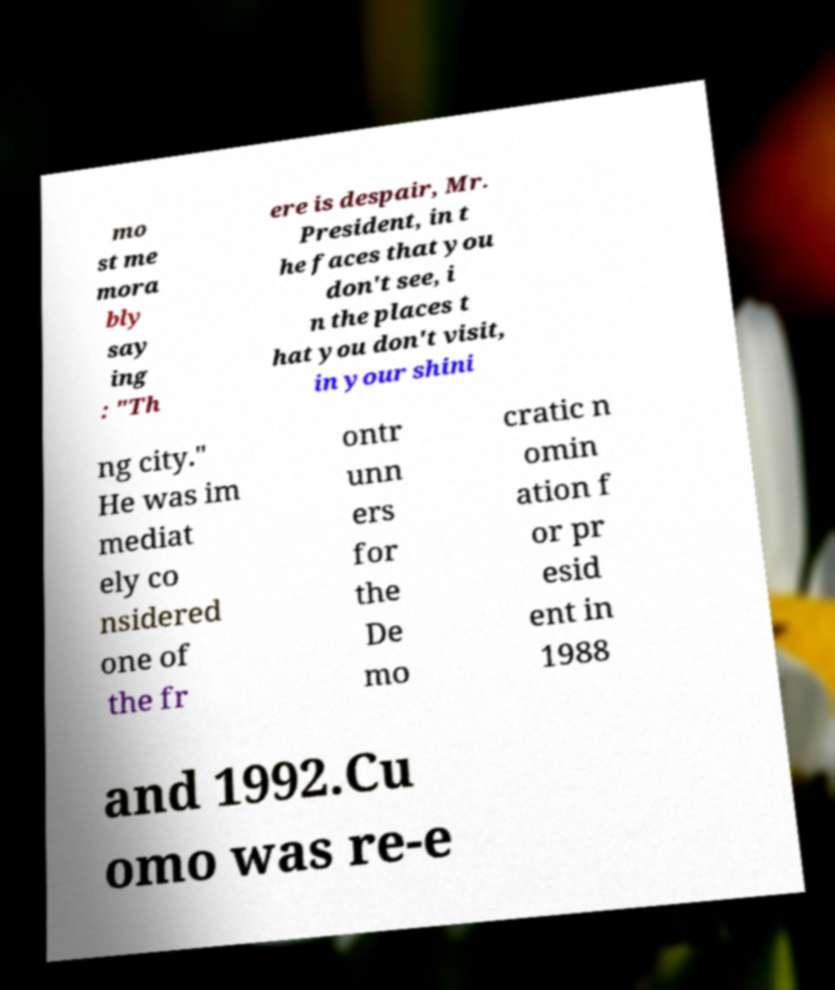Please read and relay the text visible in this image. What does it say? mo st me mora bly say ing : "Th ere is despair, Mr. President, in t he faces that you don't see, i n the places t hat you don't visit, in your shini ng city." He was im mediat ely co nsidered one of the fr ontr unn ers for the De mo cratic n omin ation f or pr esid ent in 1988 and 1992.Cu omo was re-e 